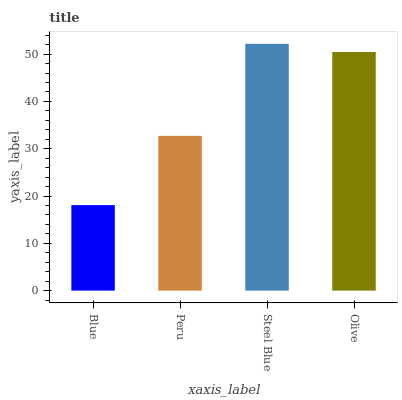Is Blue the minimum?
Answer yes or no. Yes. Is Steel Blue the maximum?
Answer yes or no. Yes. Is Peru the minimum?
Answer yes or no. No. Is Peru the maximum?
Answer yes or no. No. Is Peru greater than Blue?
Answer yes or no. Yes. Is Blue less than Peru?
Answer yes or no. Yes. Is Blue greater than Peru?
Answer yes or no. No. Is Peru less than Blue?
Answer yes or no. No. Is Olive the high median?
Answer yes or no. Yes. Is Peru the low median?
Answer yes or no. Yes. Is Blue the high median?
Answer yes or no. No. Is Olive the low median?
Answer yes or no. No. 